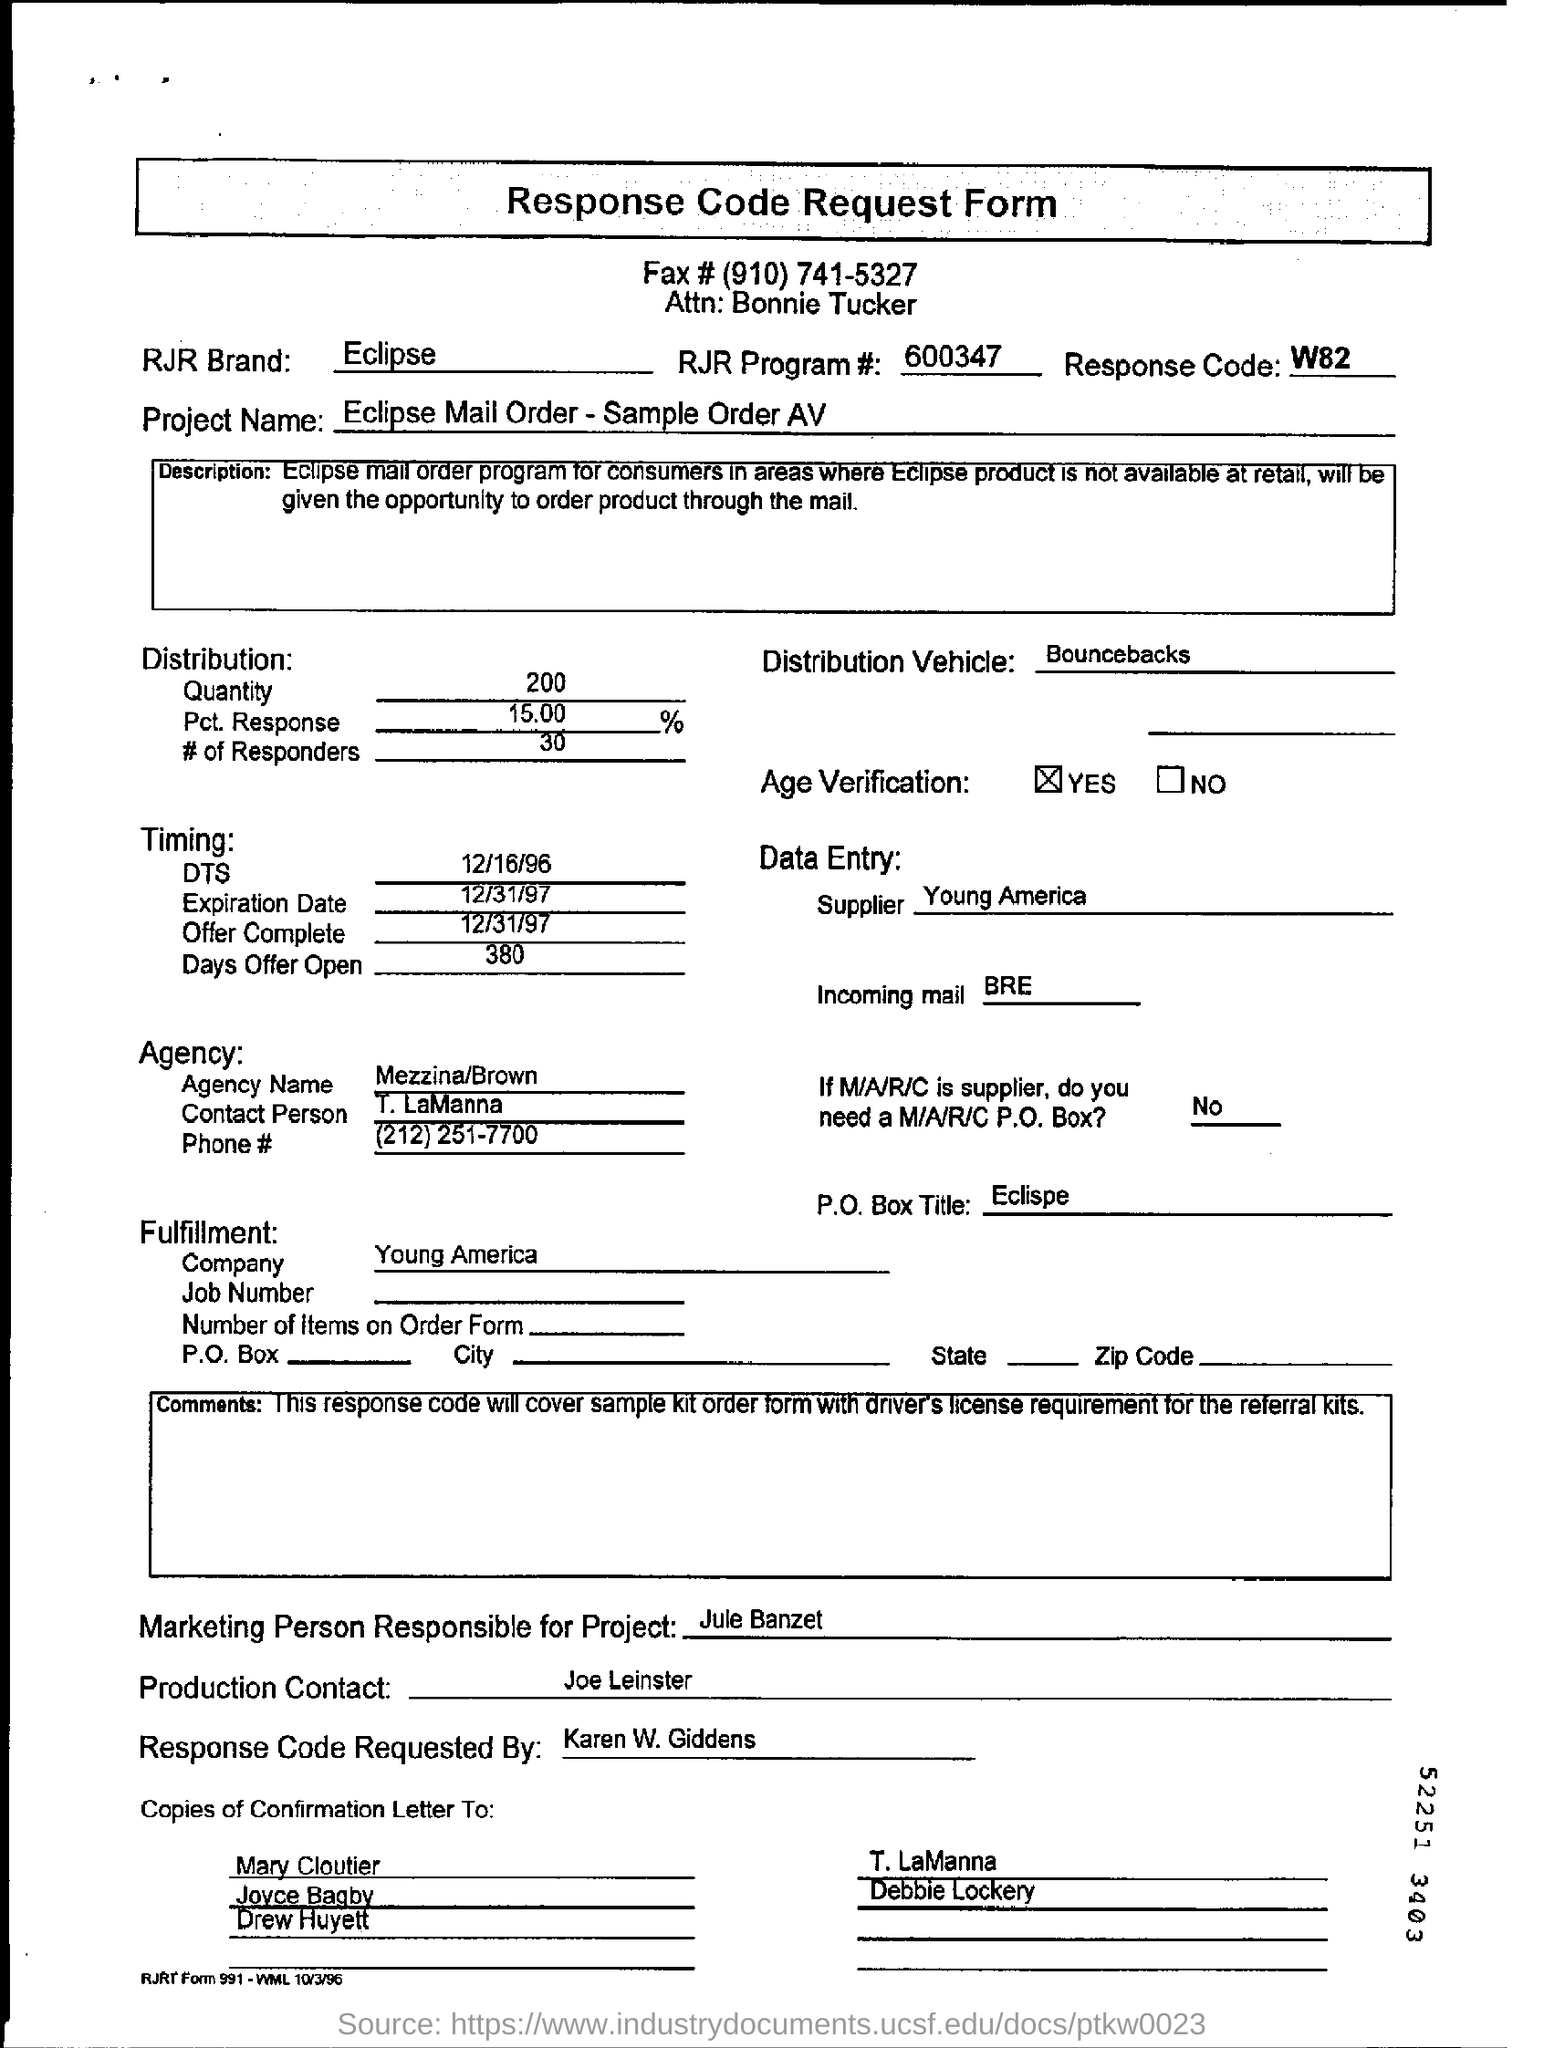Draw attention to some important aspects in this diagram. The age verification has been completed. 